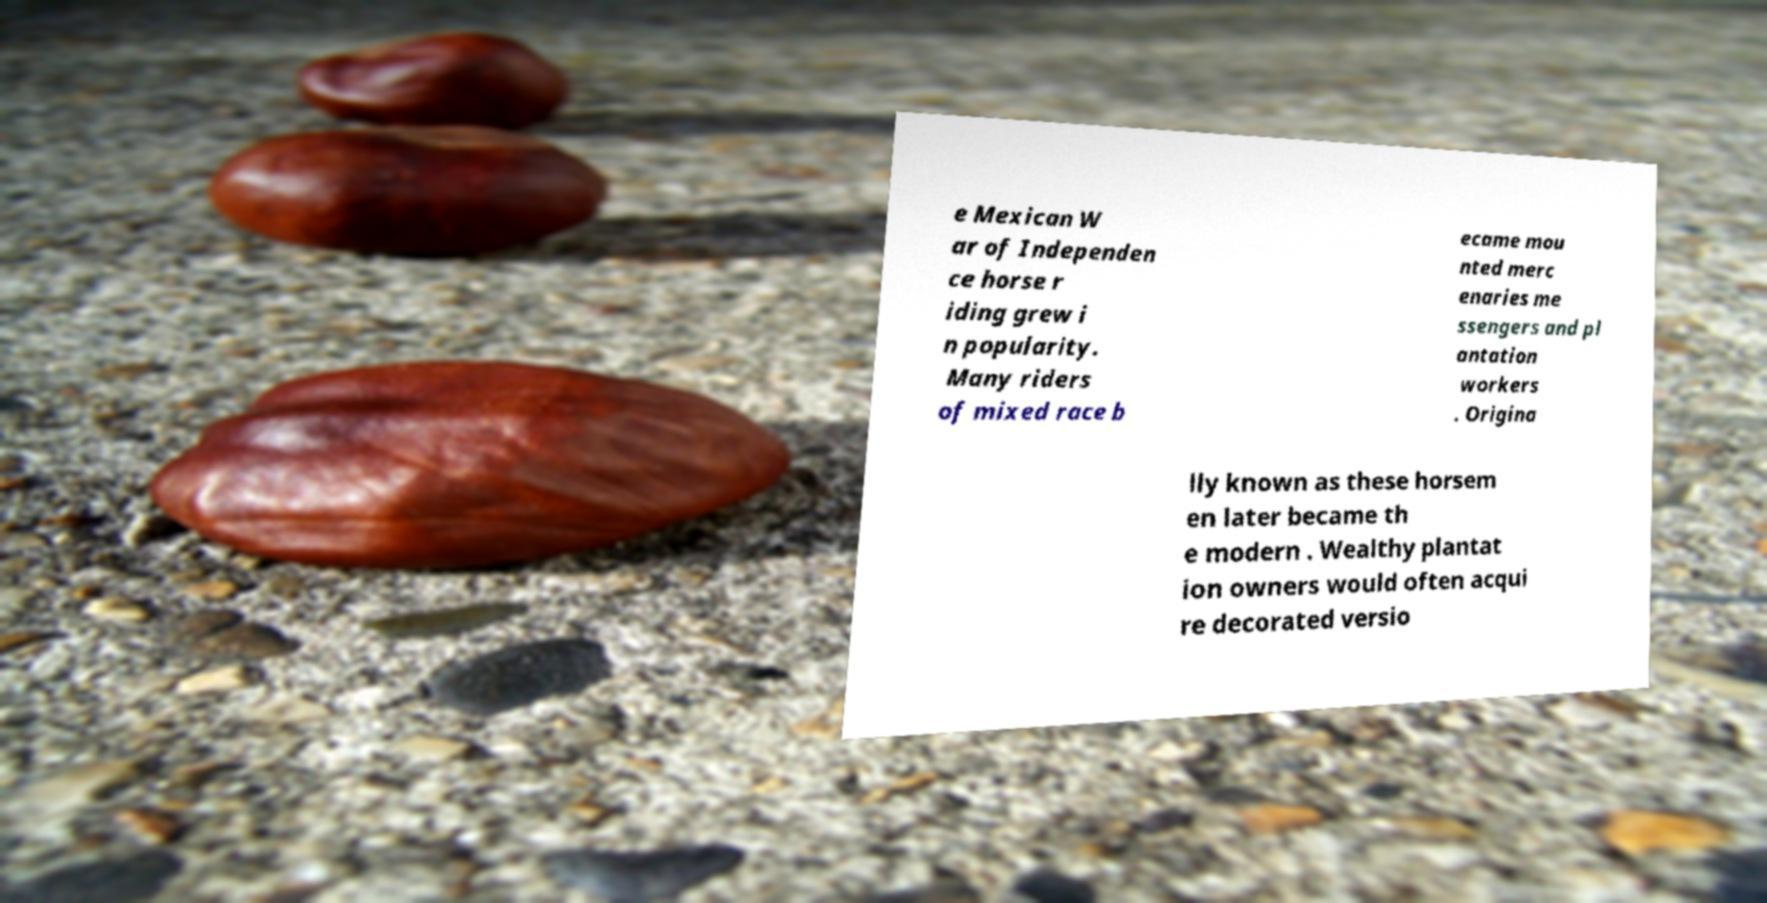Could you extract and type out the text from this image? e Mexican W ar of Independen ce horse r iding grew i n popularity. Many riders of mixed race b ecame mou nted merc enaries me ssengers and pl antation workers . Origina lly known as these horsem en later became th e modern . Wealthy plantat ion owners would often acqui re decorated versio 